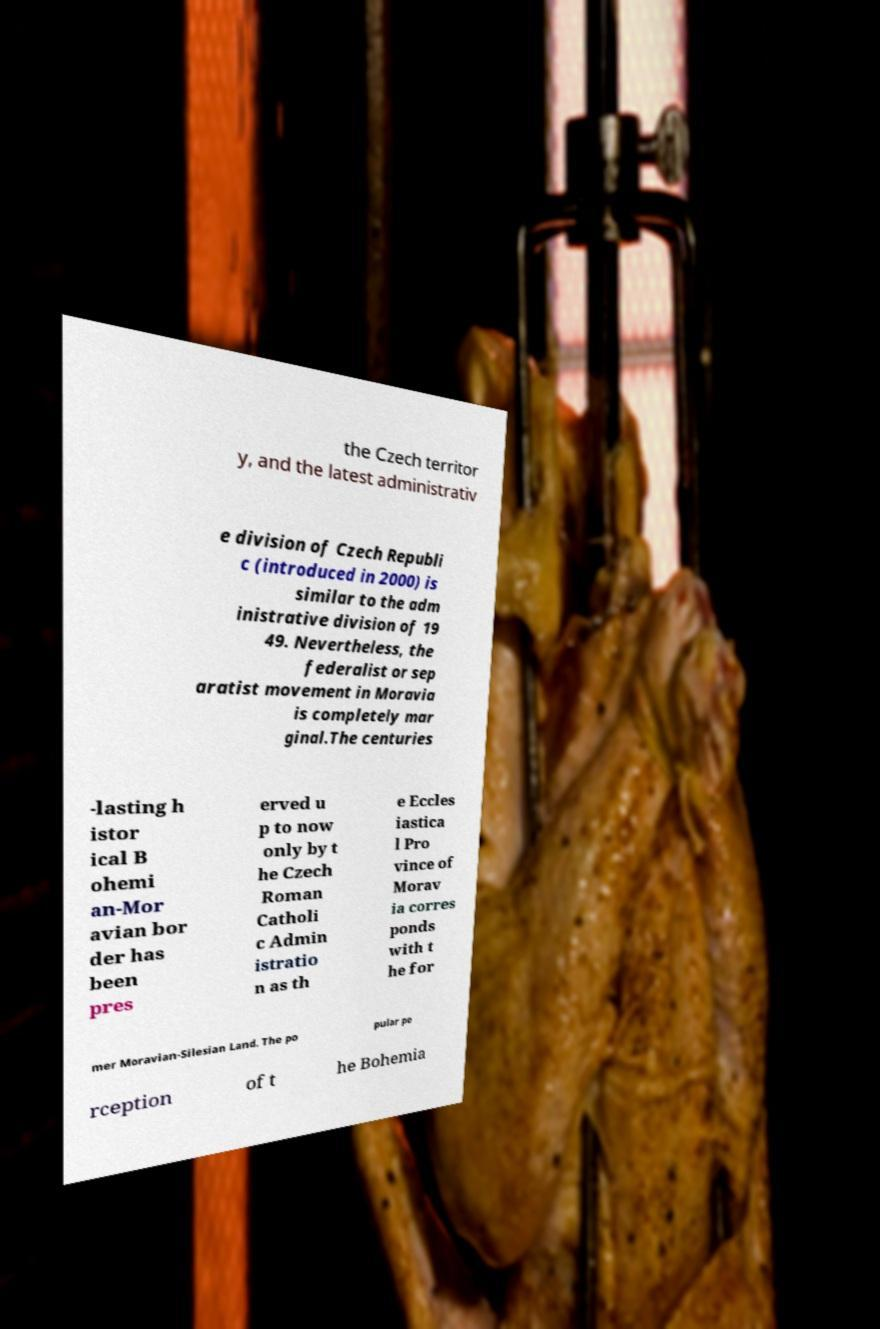I need the written content from this picture converted into text. Can you do that? the Czech territor y, and the latest administrativ e division of Czech Republi c (introduced in 2000) is similar to the adm inistrative division of 19 49. Nevertheless, the federalist or sep aratist movement in Moravia is completely mar ginal.The centuries -lasting h istor ical B ohemi an-Mor avian bor der has been pres erved u p to now only by t he Czech Roman Catholi c Admin istratio n as th e Eccles iastica l Pro vince of Morav ia corres ponds with t he for mer Moravian-Silesian Land. The po pular pe rception of t he Bohemia 